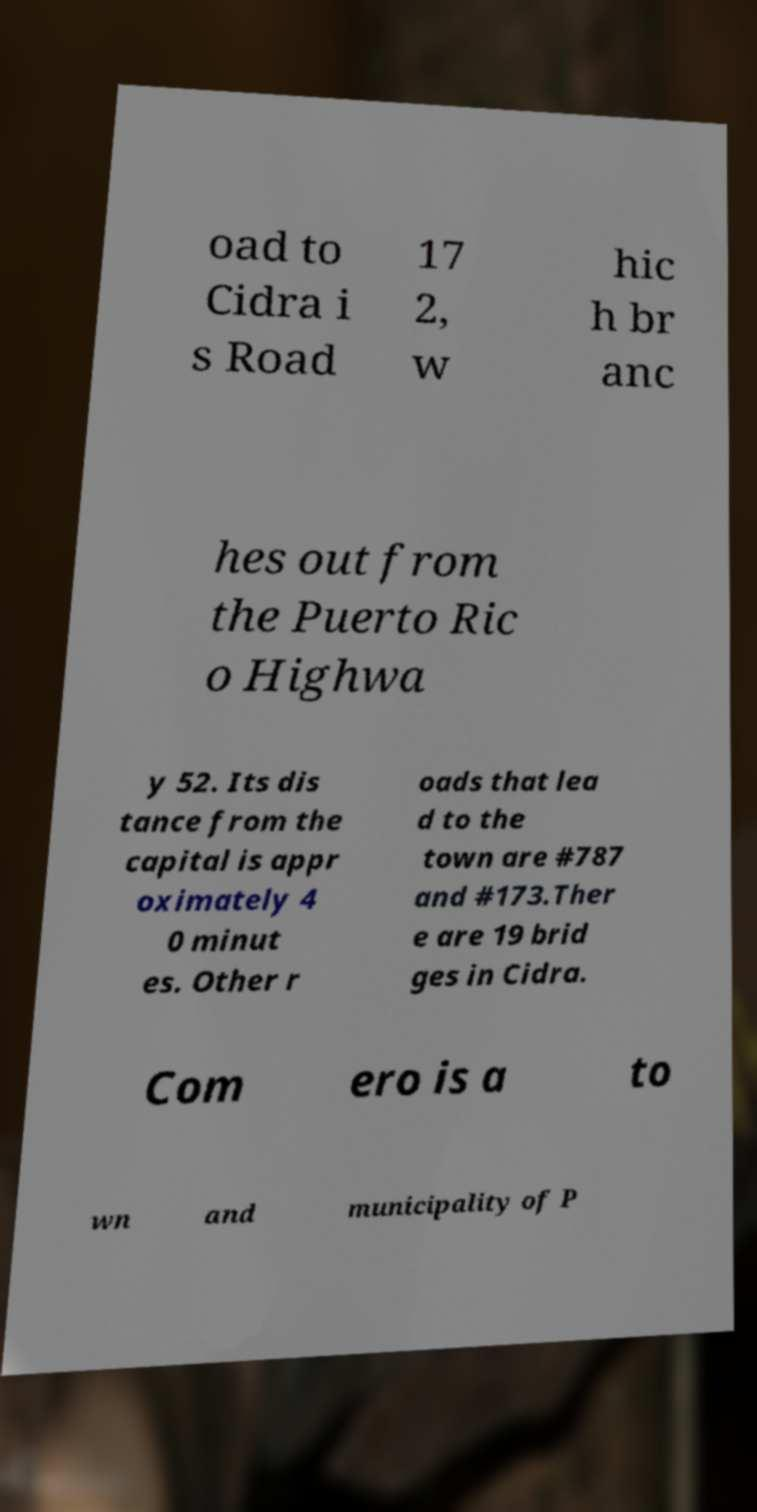What messages or text are displayed in this image? I need them in a readable, typed format. oad to Cidra i s Road 17 2, w hic h br anc hes out from the Puerto Ric o Highwa y 52. Its dis tance from the capital is appr oximately 4 0 minut es. Other r oads that lea d to the town are #787 and #173.Ther e are 19 brid ges in Cidra. Com ero is a to wn and municipality of P 